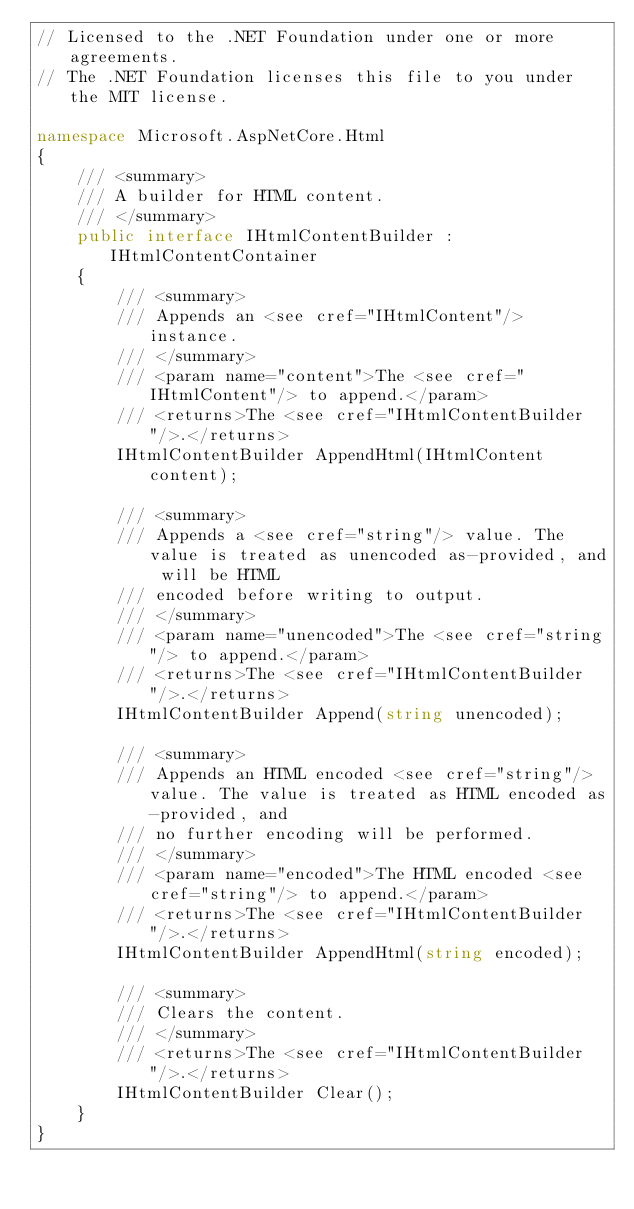<code> <loc_0><loc_0><loc_500><loc_500><_C#_>// Licensed to the .NET Foundation under one or more agreements.
// The .NET Foundation licenses this file to you under the MIT license.

namespace Microsoft.AspNetCore.Html
{
    /// <summary>
    /// A builder for HTML content.
    /// </summary>
    public interface IHtmlContentBuilder : IHtmlContentContainer
    {
        /// <summary>
        /// Appends an <see cref="IHtmlContent"/> instance.
        /// </summary>
        /// <param name="content">The <see cref="IHtmlContent"/> to append.</param>
        /// <returns>The <see cref="IHtmlContentBuilder"/>.</returns>
        IHtmlContentBuilder AppendHtml(IHtmlContent content);

        /// <summary>
        /// Appends a <see cref="string"/> value. The value is treated as unencoded as-provided, and will be HTML
        /// encoded before writing to output.
        /// </summary>
        /// <param name="unencoded">The <see cref="string"/> to append.</param>
        /// <returns>The <see cref="IHtmlContentBuilder"/>.</returns>
        IHtmlContentBuilder Append(string unencoded);

        /// <summary>
        /// Appends an HTML encoded <see cref="string"/> value. The value is treated as HTML encoded as-provided, and
        /// no further encoding will be performed.
        /// </summary>
        /// <param name="encoded">The HTML encoded <see cref="string"/> to append.</param>
        /// <returns>The <see cref="IHtmlContentBuilder"/>.</returns>
        IHtmlContentBuilder AppendHtml(string encoded);

        /// <summary>
        /// Clears the content.
        /// </summary>
        /// <returns>The <see cref="IHtmlContentBuilder"/>.</returns>
        IHtmlContentBuilder Clear();
    }
}
</code> 